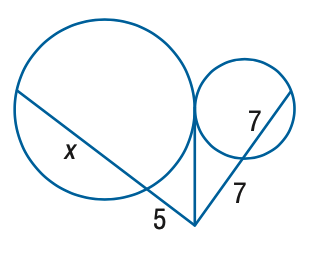Question: Find the variable of x to the nearest tenth. Assume that segments that appear to be tangent are tangent.
Choices:
A. 14.1
B. 14.6
C. 15.1
D. 15.6
Answer with the letter. Answer: B 